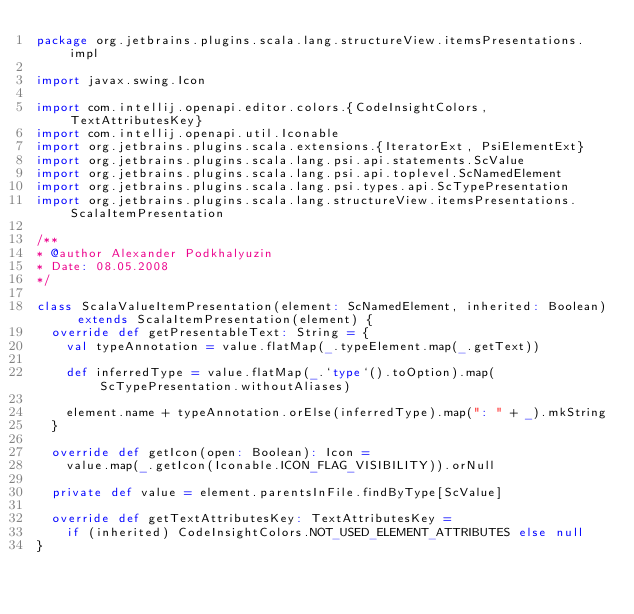<code> <loc_0><loc_0><loc_500><loc_500><_Scala_>package org.jetbrains.plugins.scala.lang.structureView.itemsPresentations.impl

import javax.swing.Icon

import com.intellij.openapi.editor.colors.{CodeInsightColors, TextAttributesKey}
import com.intellij.openapi.util.Iconable
import org.jetbrains.plugins.scala.extensions.{IteratorExt, PsiElementExt}
import org.jetbrains.plugins.scala.lang.psi.api.statements.ScValue
import org.jetbrains.plugins.scala.lang.psi.api.toplevel.ScNamedElement
import org.jetbrains.plugins.scala.lang.psi.types.api.ScTypePresentation
import org.jetbrains.plugins.scala.lang.structureView.itemsPresentations.ScalaItemPresentation

/**
* @author Alexander Podkhalyuzin
* Date: 08.05.2008
*/

class ScalaValueItemPresentation(element: ScNamedElement, inherited: Boolean) extends ScalaItemPresentation(element) {
  override def getPresentableText: String = {
    val typeAnnotation = value.flatMap(_.typeElement.map(_.getText))

    def inferredType = value.flatMap(_.`type`().toOption).map(ScTypePresentation.withoutAliases)

    element.name + typeAnnotation.orElse(inferredType).map(": " + _).mkString
  }

  override def getIcon(open: Boolean): Icon =
    value.map(_.getIcon(Iconable.ICON_FLAG_VISIBILITY)).orNull

  private def value = element.parentsInFile.findByType[ScValue]

  override def getTextAttributesKey: TextAttributesKey =
    if (inherited) CodeInsightColors.NOT_USED_ELEMENT_ATTRIBUTES else null
}
</code> 